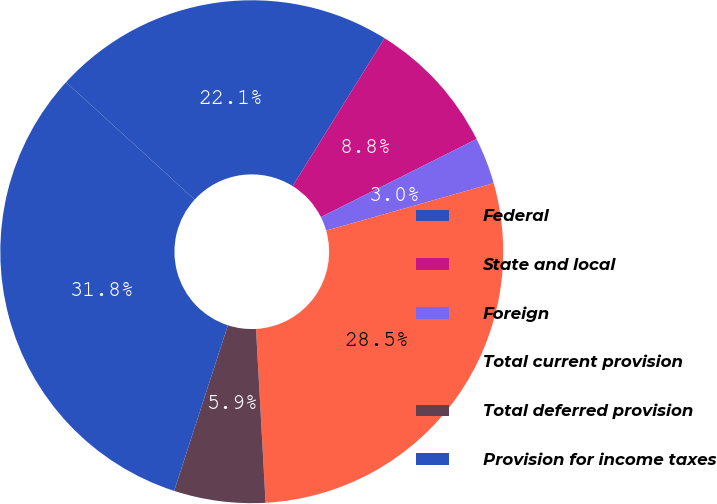Convert chart to OTSL. <chart><loc_0><loc_0><loc_500><loc_500><pie_chart><fcel>Federal<fcel>State and local<fcel>Foreign<fcel>Total current provision<fcel>Total deferred provision<fcel>Provision for income taxes<nl><fcel>22.08%<fcel>8.75%<fcel>3.0%<fcel>28.52%<fcel>5.87%<fcel>31.78%<nl></chart> 